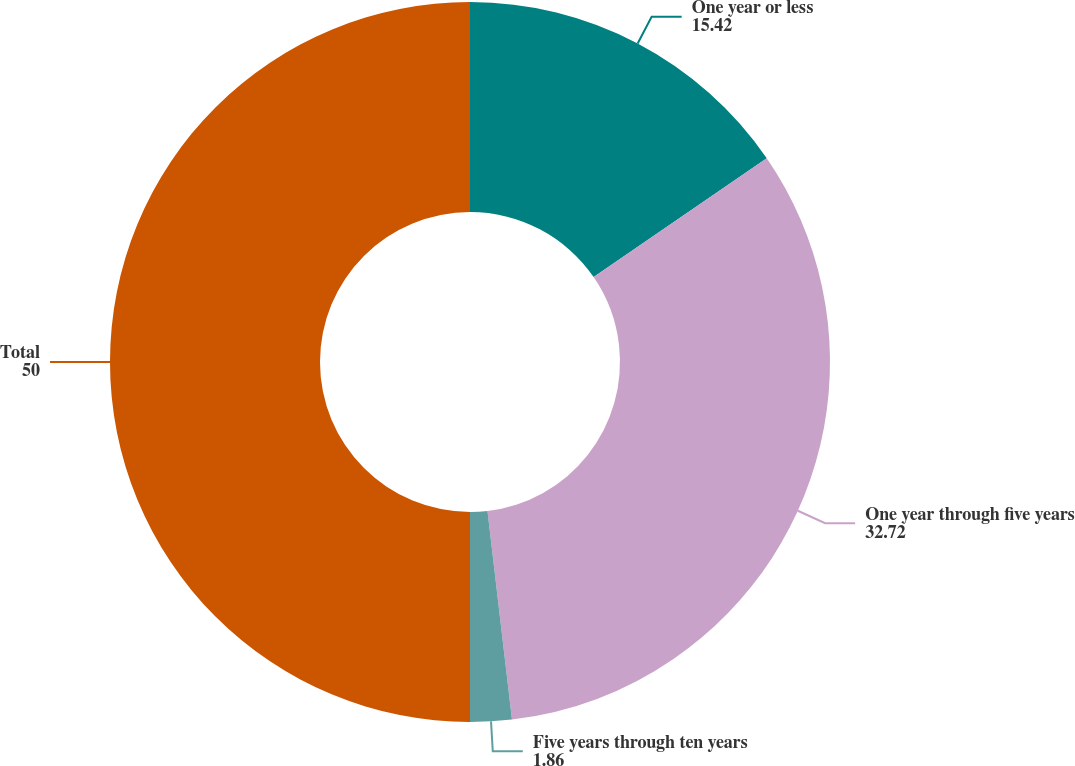Convert chart to OTSL. <chart><loc_0><loc_0><loc_500><loc_500><pie_chart><fcel>One year or less<fcel>One year through five years<fcel>Five years through ten years<fcel>Total<nl><fcel>15.42%<fcel>32.72%<fcel>1.86%<fcel>50.0%<nl></chart> 